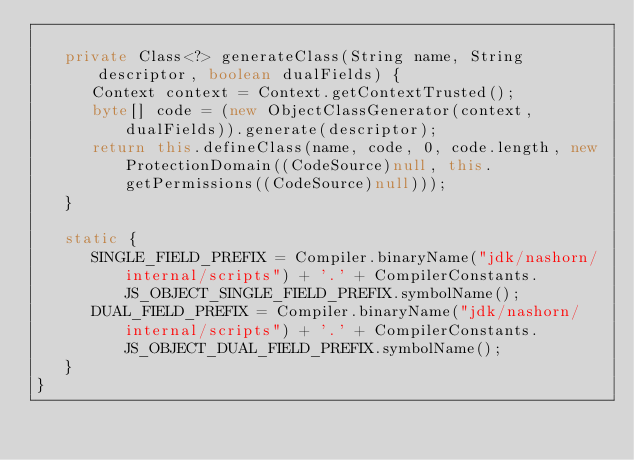<code> <loc_0><loc_0><loc_500><loc_500><_Java_>
   private Class<?> generateClass(String name, String descriptor, boolean dualFields) {
      Context context = Context.getContextTrusted();
      byte[] code = (new ObjectClassGenerator(context, dualFields)).generate(descriptor);
      return this.defineClass(name, code, 0, code.length, new ProtectionDomain((CodeSource)null, this.getPermissions((CodeSource)null)));
   }

   static {
      SINGLE_FIELD_PREFIX = Compiler.binaryName("jdk/nashorn/internal/scripts") + '.' + CompilerConstants.JS_OBJECT_SINGLE_FIELD_PREFIX.symbolName();
      DUAL_FIELD_PREFIX = Compiler.binaryName("jdk/nashorn/internal/scripts") + '.' + CompilerConstants.JS_OBJECT_DUAL_FIELD_PREFIX.symbolName();
   }
}
</code> 